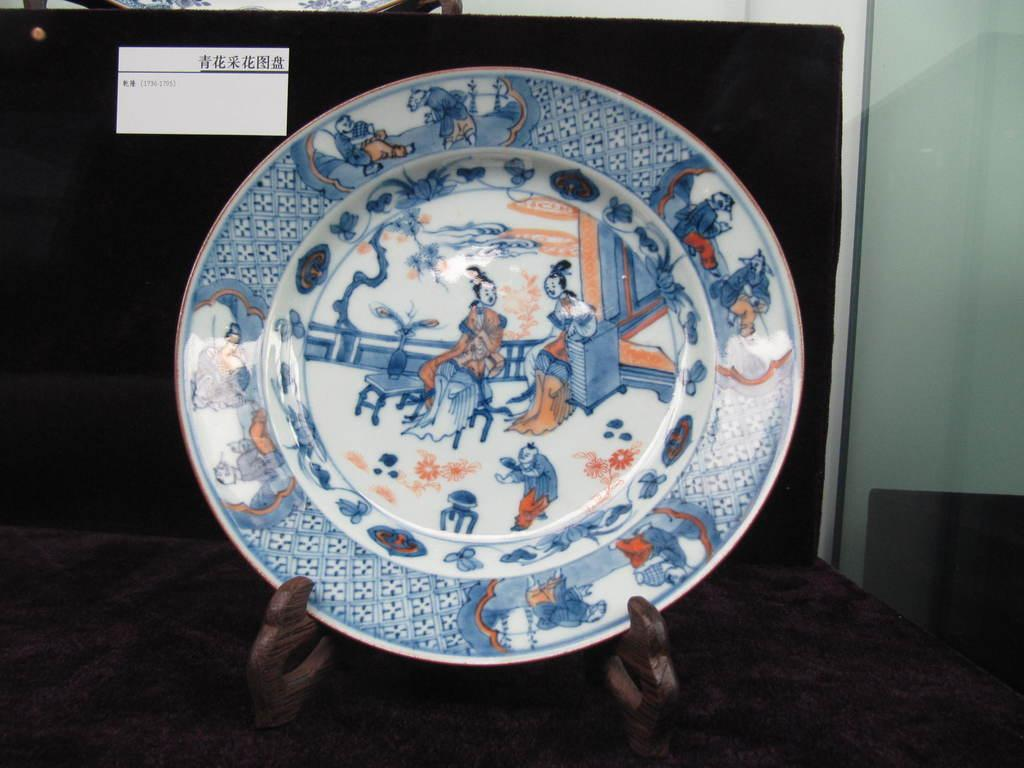What is the main object in the center of the image? There is a ceramic plate in the center of the image. What can be seen in the background of the image? There is a label on a blackboard in the background. What type of architectural feature is on the right side of the image? There appears to be a glass window on the right side of the image. What type of poison is being used to clean the ceramic plate in the image? There is no indication of poison or cleaning in the image; it only shows a ceramic plate in the center. 